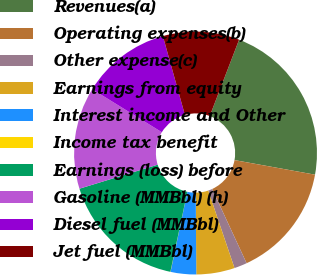<chart> <loc_0><loc_0><loc_500><loc_500><pie_chart><fcel>Revenues(a)<fcel>Operating expenses(b)<fcel>Other expense(c)<fcel>Earnings from equity<fcel>Interest income and Other<fcel>Income tax benefit<fcel>Earnings (loss) before<fcel>Gasoline (MMBbl) (h)<fcel>Diesel fuel (MMBbl)<fcel>Jet fuel (MMBbl)<nl><fcel>22.01%<fcel>15.24%<fcel>1.71%<fcel>5.1%<fcel>3.4%<fcel>0.02%<fcel>16.93%<fcel>13.55%<fcel>11.86%<fcel>10.17%<nl></chart> 